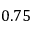<formula> <loc_0><loc_0><loc_500><loc_500>0 . 7 5</formula> 